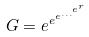Convert formula to latex. <formula><loc_0><loc_0><loc_500><loc_500>G = e ^ { e ^ { e ^ { \dots ^ { e ^ { r } } } } }</formula> 